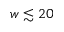<formula> <loc_0><loc_0><loc_500><loc_500>w \lesssim 2 0</formula> 